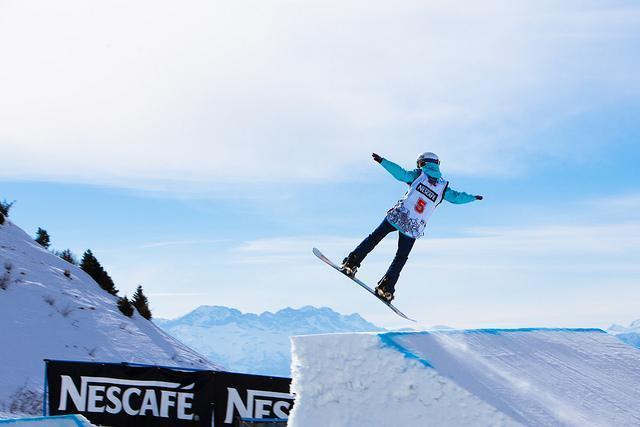How many chairs at the table?
Give a very brief answer. 0. 